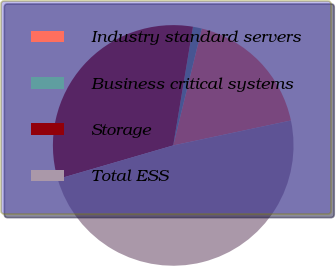<chart> <loc_0><loc_0><loc_500><loc_500><pie_chart><fcel>Industry standard servers<fcel>Business critical systems<fcel>Storage<fcel>Total ESS<nl><fcel>17.86%<fcel>1.19%<fcel>32.14%<fcel>48.81%<nl></chart> 